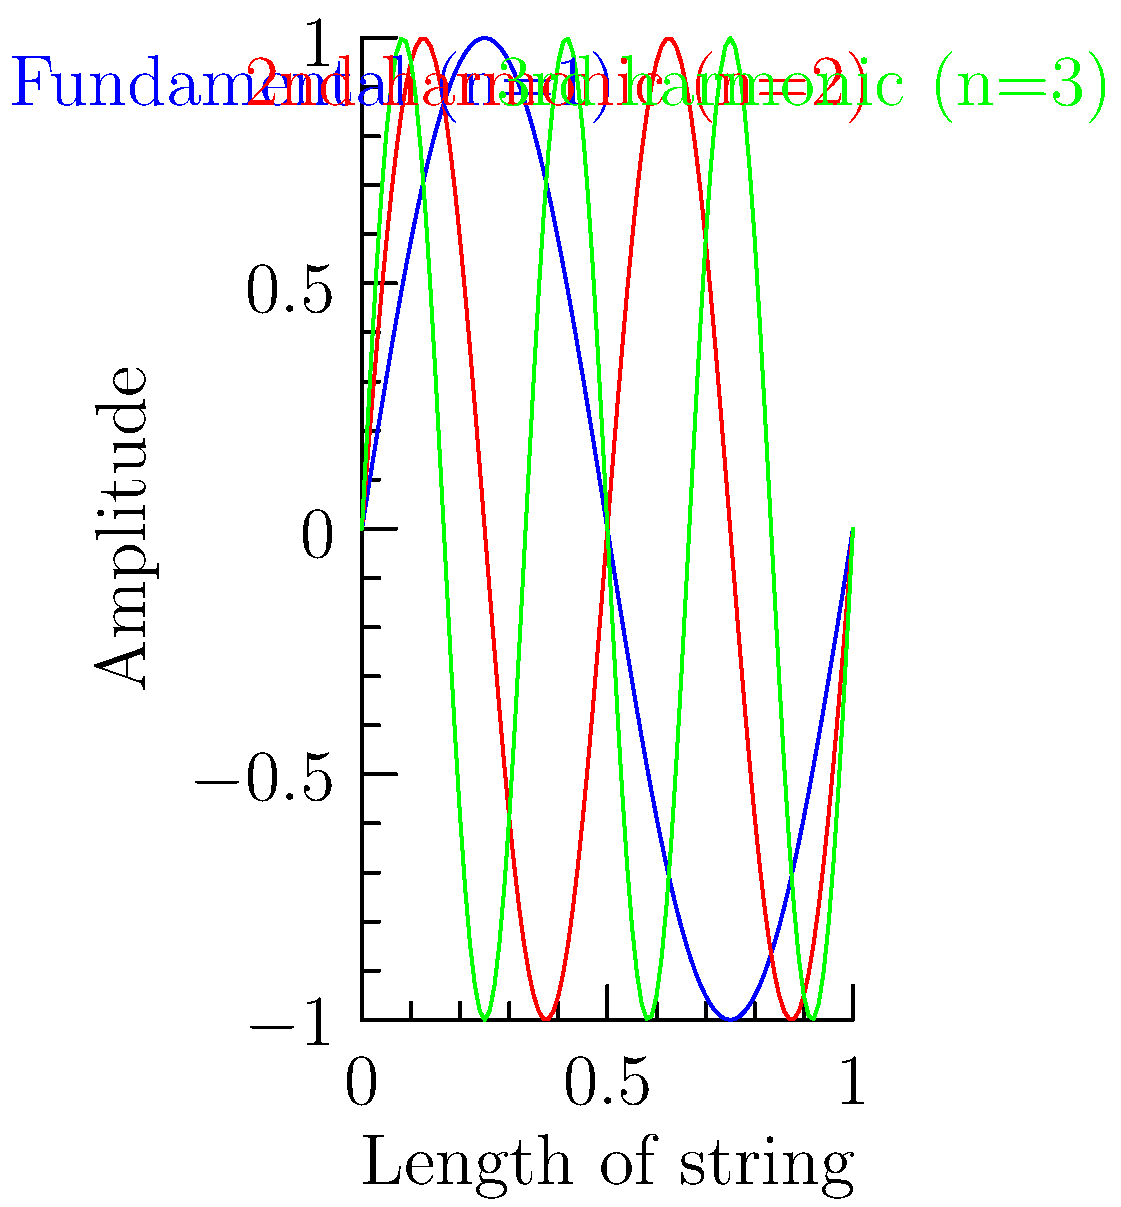In the context of a vibrating string, how does the wavelength of the third harmonic (n=3) compare to the fundamental frequency (n=1)? Relate your answer to the musical concept of octaves. To answer this question, let's follow these steps:

1) The fundamental frequency (n=1) represents the longest wavelength that can fit in the string, with nodes at both ends. This is shown by the blue curve in the diagram.

2) The third harmonic (n=3), represented by the green curve, has three times as many antinodes as the fundamental.

3) The wavelength (λ) is inversely proportional to the number of antinodes. So, if we call the wavelength of the fundamental λ₁, then the wavelength of the third harmonic λ₃ is:

   $$λ₃ = \frac{1}{3}λ₁$$

4) In music theory, an octave represents a doubling or halving of frequency. The frequency (f) is inversely proportional to wavelength:

   $$f = \frac{v}{λ}$$

   where v is the wave velocity (constant for a given string).

5) Therefore, the frequency of the third harmonic is three times that of the fundamental:

   $$f₃ = 3f₁$$

6) In terms of octaves, we can express this relationship logarithmically:

   $$log₂(\frac{f₃}{f₁}) = log₂(3) ≈ 1.585$$

This means the third harmonic is about 1.585 octaves above the fundamental.
Answer: The wavelength of the third harmonic is 1/3 of the fundamental, corresponding to approximately 1.585 octaves higher. 